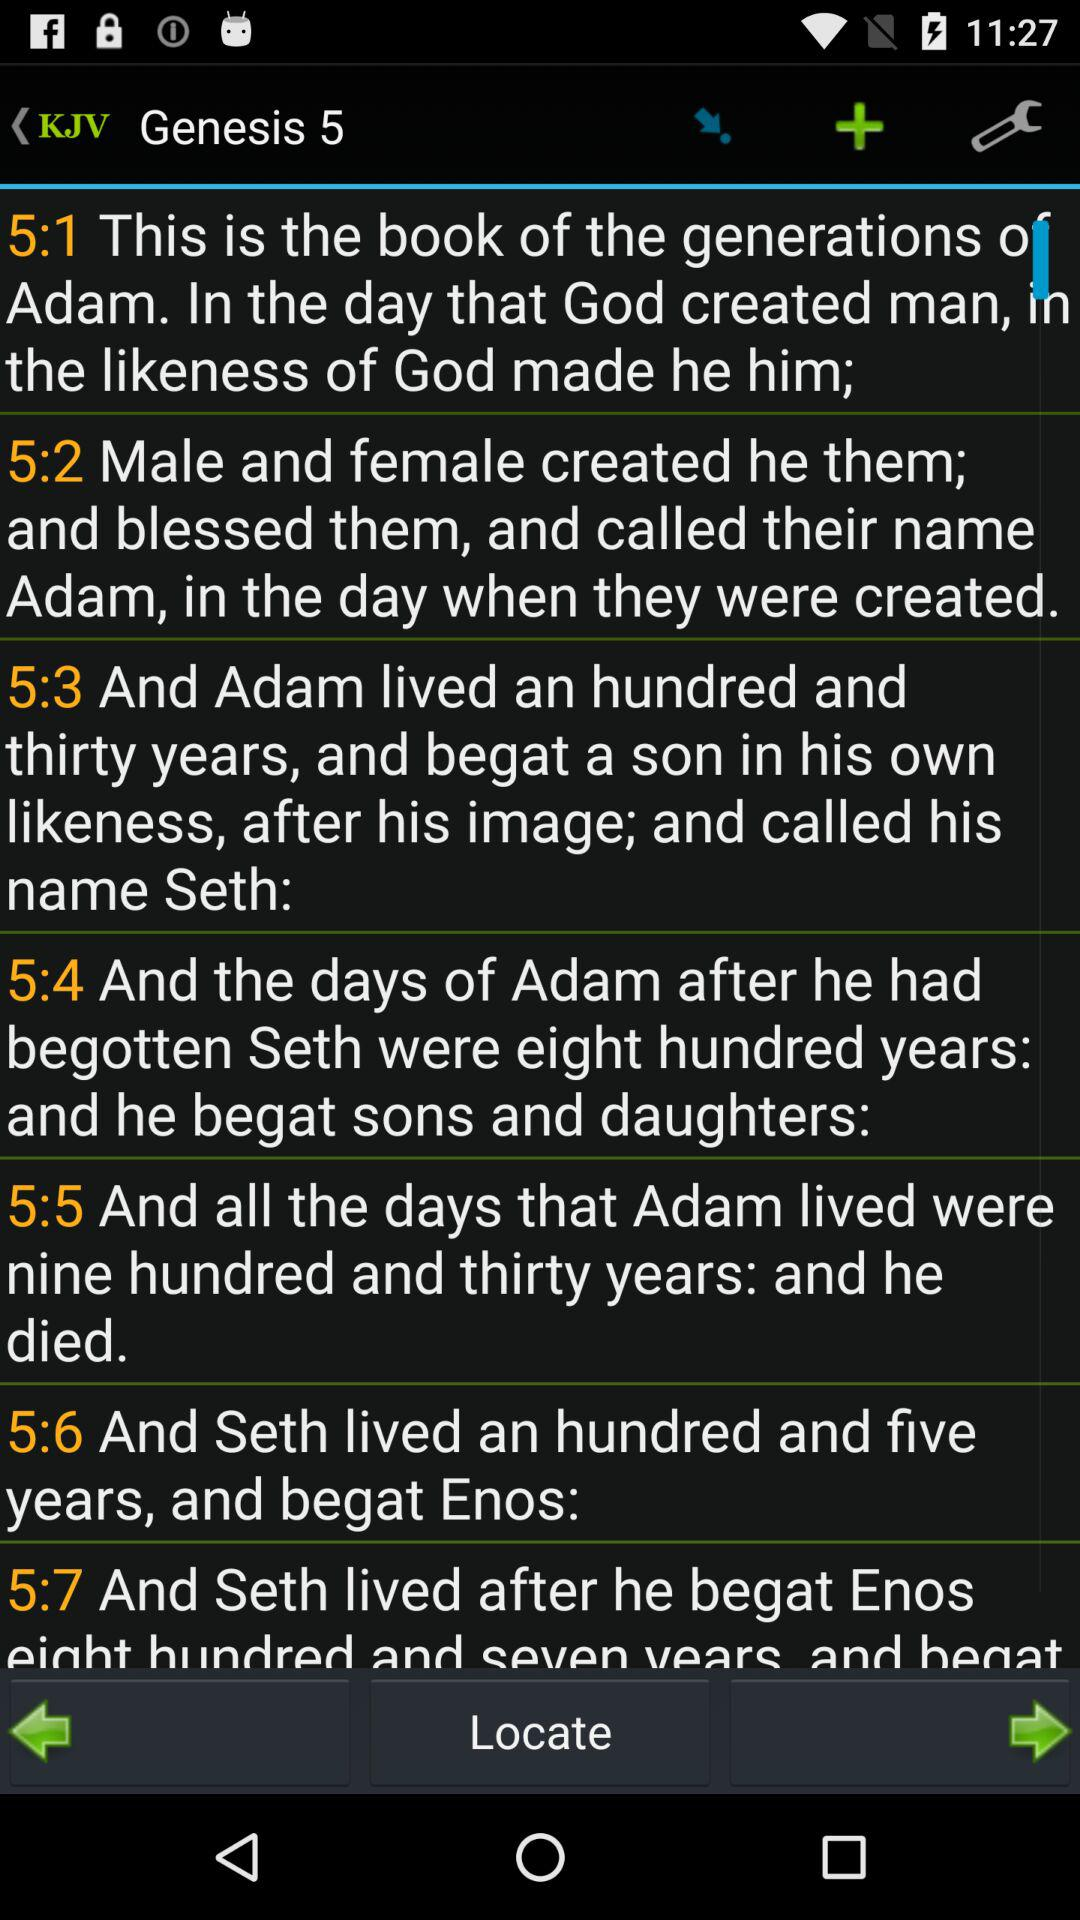What is the name of Seth's son? The name of Seth's son is Enos. 